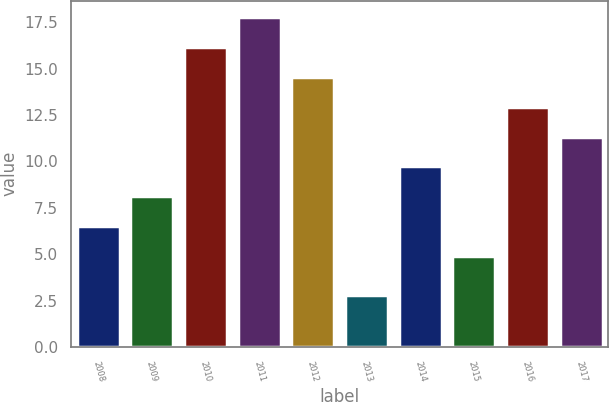Convert chart. <chart><loc_0><loc_0><loc_500><loc_500><bar_chart><fcel>2008<fcel>2009<fcel>2010<fcel>2011<fcel>2012<fcel>2013<fcel>2014<fcel>2015<fcel>2016<fcel>2017<nl><fcel>6.51<fcel>8.12<fcel>16.17<fcel>17.78<fcel>14.56<fcel>2.8<fcel>9.73<fcel>4.9<fcel>12.95<fcel>11.34<nl></chart> 